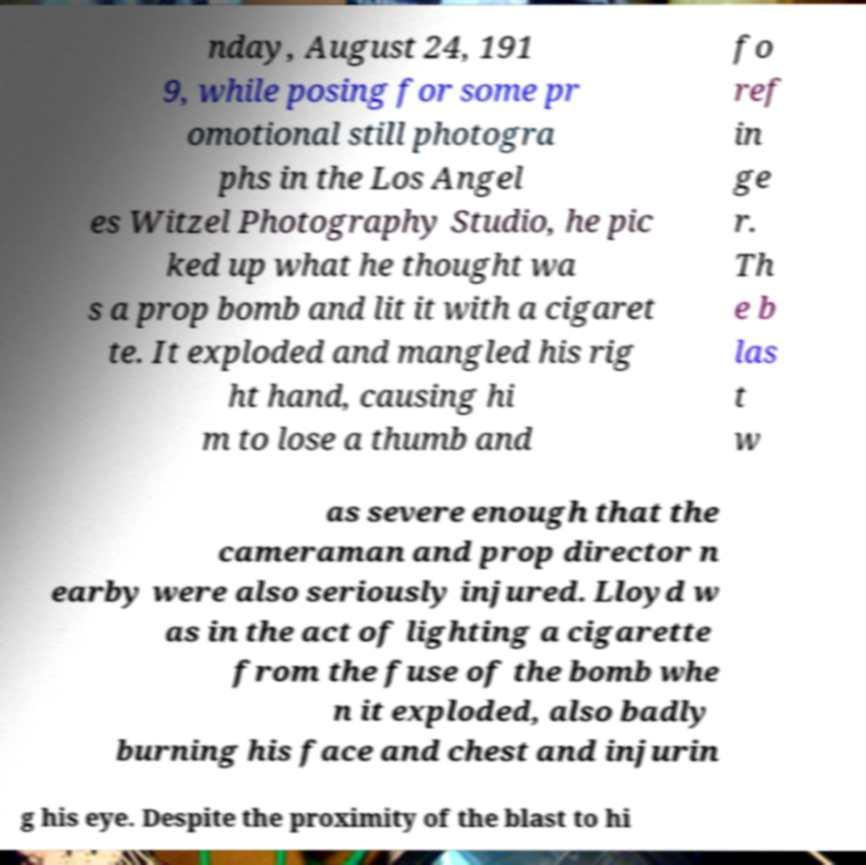Could you assist in decoding the text presented in this image and type it out clearly? nday, August 24, 191 9, while posing for some pr omotional still photogra phs in the Los Angel es Witzel Photography Studio, he pic ked up what he thought wa s a prop bomb and lit it with a cigaret te. It exploded and mangled his rig ht hand, causing hi m to lose a thumb and fo ref in ge r. Th e b las t w as severe enough that the cameraman and prop director n earby were also seriously injured. Lloyd w as in the act of lighting a cigarette from the fuse of the bomb whe n it exploded, also badly burning his face and chest and injurin g his eye. Despite the proximity of the blast to hi 